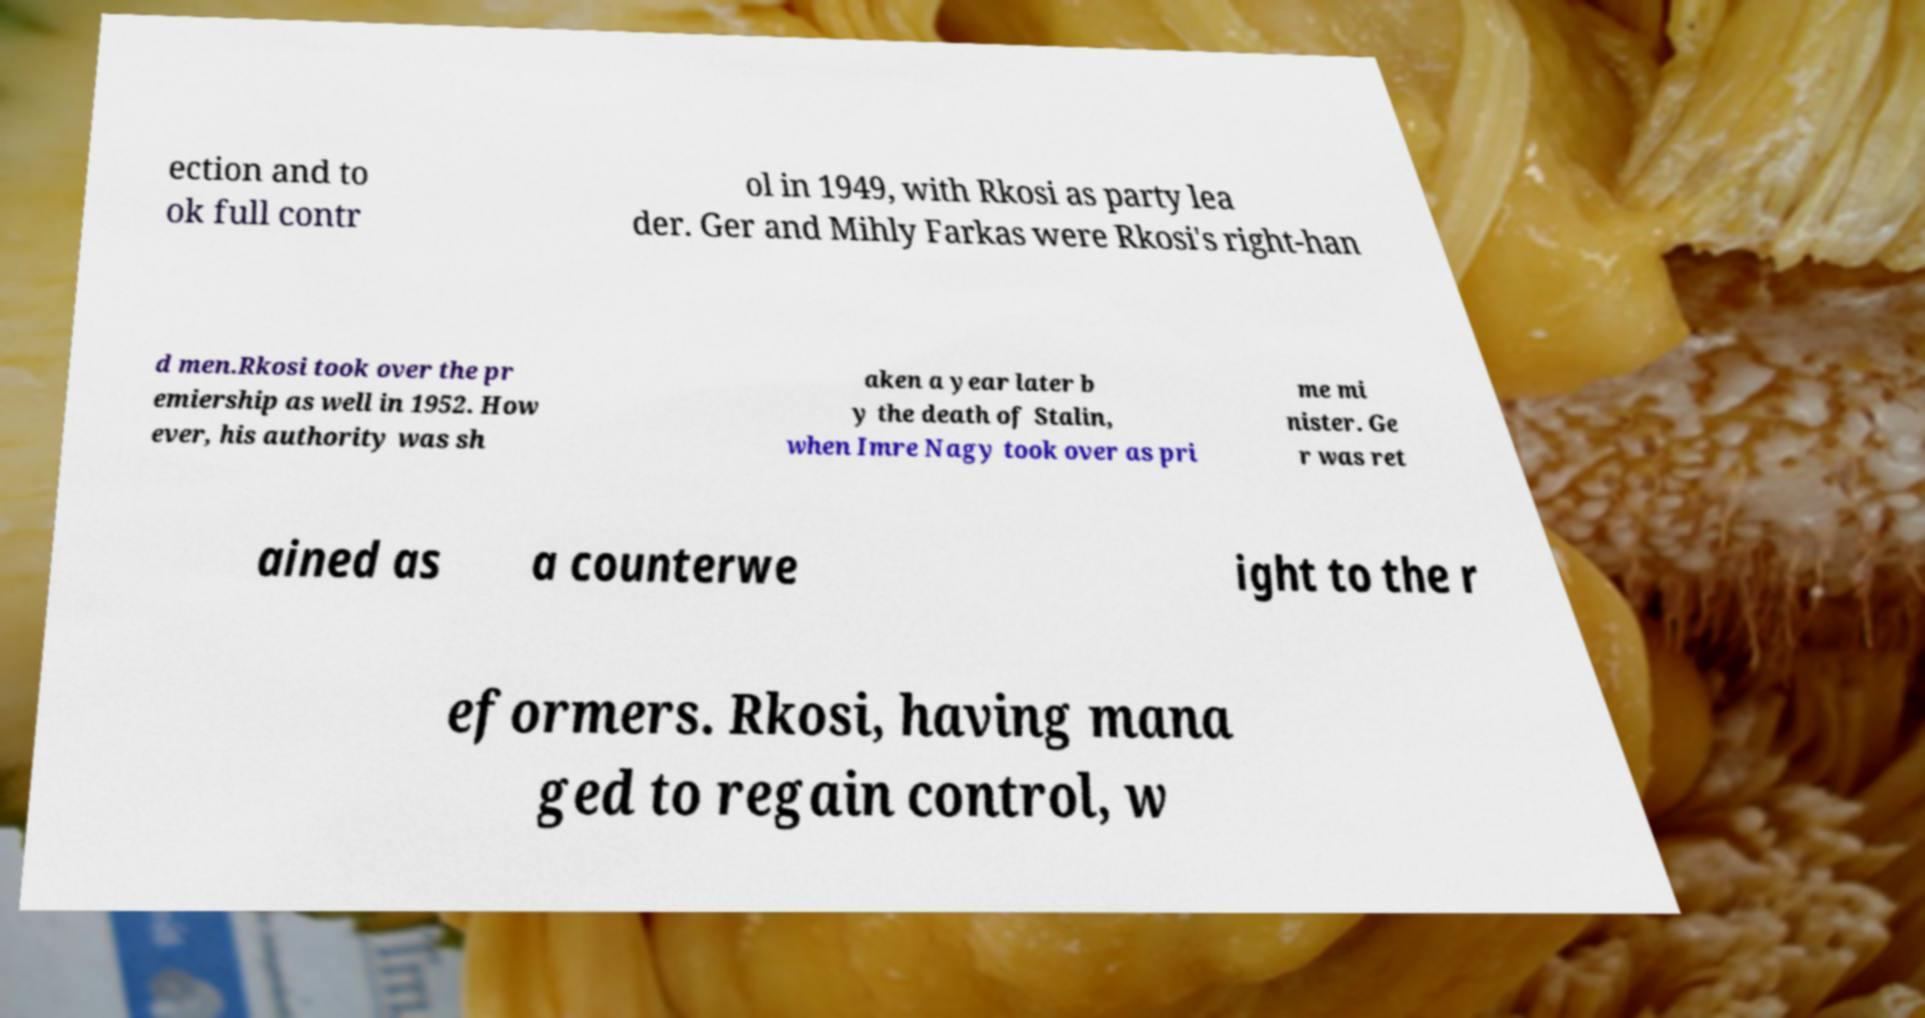For documentation purposes, I need the text within this image transcribed. Could you provide that? ection and to ok full contr ol in 1949, with Rkosi as party lea der. Ger and Mihly Farkas were Rkosi's right-han d men.Rkosi took over the pr emiership as well in 1952. How ever, his authority was sh aken a year later b y the death of Stalin, when Imre Nagy took over as pri me mi nister. Ge r was ret ained as a counterwe ight to the r eformers. Rkosi, having mana ged to regain control, w 